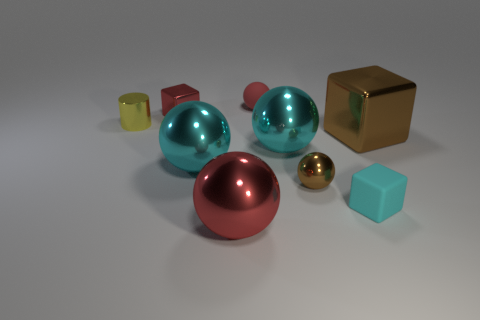Is the color of the tiny metallic ball the same as the big block?
Give a very brief answer. Yes. Is there anything else that has the same shape as the tiny yellow shiny thing?
Keep it short and to the point. No. What is the size of the red ball that is behind the metallic thing that is behind the small yellow metal thing?
Your answer should be very brief. Small. What color is the cylinder that is made of the same material as the big brown thing?
Ensure brevity in your answer.  Yellow. What number of red metallic spheres are the same size as the red matte sphere?
Your answer should be very brief. 0. What number of brown objects are large spheres or tiny metallic objects?
Keep it short and to the point. 1. How many things are either small red cubes or big metallic things that are on the left side of the big brown block?
Keep it short and to the point. 4. What is the material of the cube that is behind the small yellow thing?
Your answer should be compact. Metal. There is a cyan object that is the same size as the yellow thing; what shape is it?
Offer a very short reply. Cube. Is there a small brown thing of the same shape as the large brown object?
Make the answer very short. No. 